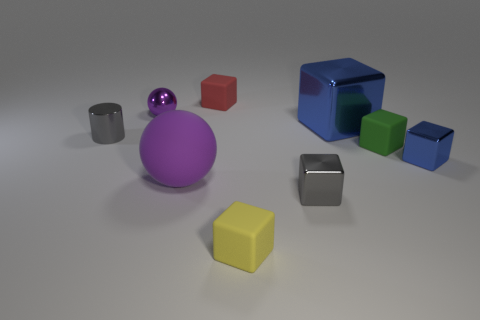What material is the thing that is to the right of the purple metallic sphere and left of the tiny red matte cube?
Offer a very short reply. Rubber. How many red things are the same shape as the purple rubber thing?
Offer a terse response. 0. How big is the gray metallic thing right of the tiny cube that is in front of the small gray metal thing to the right of the small purple metallic thing?
Your answer should be very brief. Small. Is the number of objects right of the small purple metallic sphere greater than the number of tiny metal balls?
Offer a terse response. Yes. Is there a big rubber object?
Give a very brief answer. Yes. How many purple things have the same size as the green matte object?
Offer a terse response. 1. Is the number of tiny purple shiny things that are in front of the tiny blue cube greater than the number of purple matte spheres on the right side of the big rubber ball?
Provide a succinct answer. No. There is a red thing that is the same size as the green rubber object; what is it made of?
Keep it short and to the point. Rubber. What is the shape of the purple shiny thing?
Your answer should be compact. Sphere. What number of gray things are balls or small cylinders?
Keep it short and to the point. 1. 